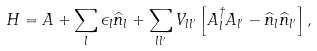Convert formula to latex. <formula><loc_0><loc_0><loc_500><loc_500>H = A + \sum _ { l } \epsilon _ { l } \widehat { n } _ { l } + \sum _ { l l ^ { \prime } } V _ { l l ^ { \prime } } \left [ A _ { l } ^ { \dagger } A _ { l ^ { \prime } } - \widehat { n } _ { l } \widehat { n } _ { l ^ { \prime } } \right ] ,</formula> 